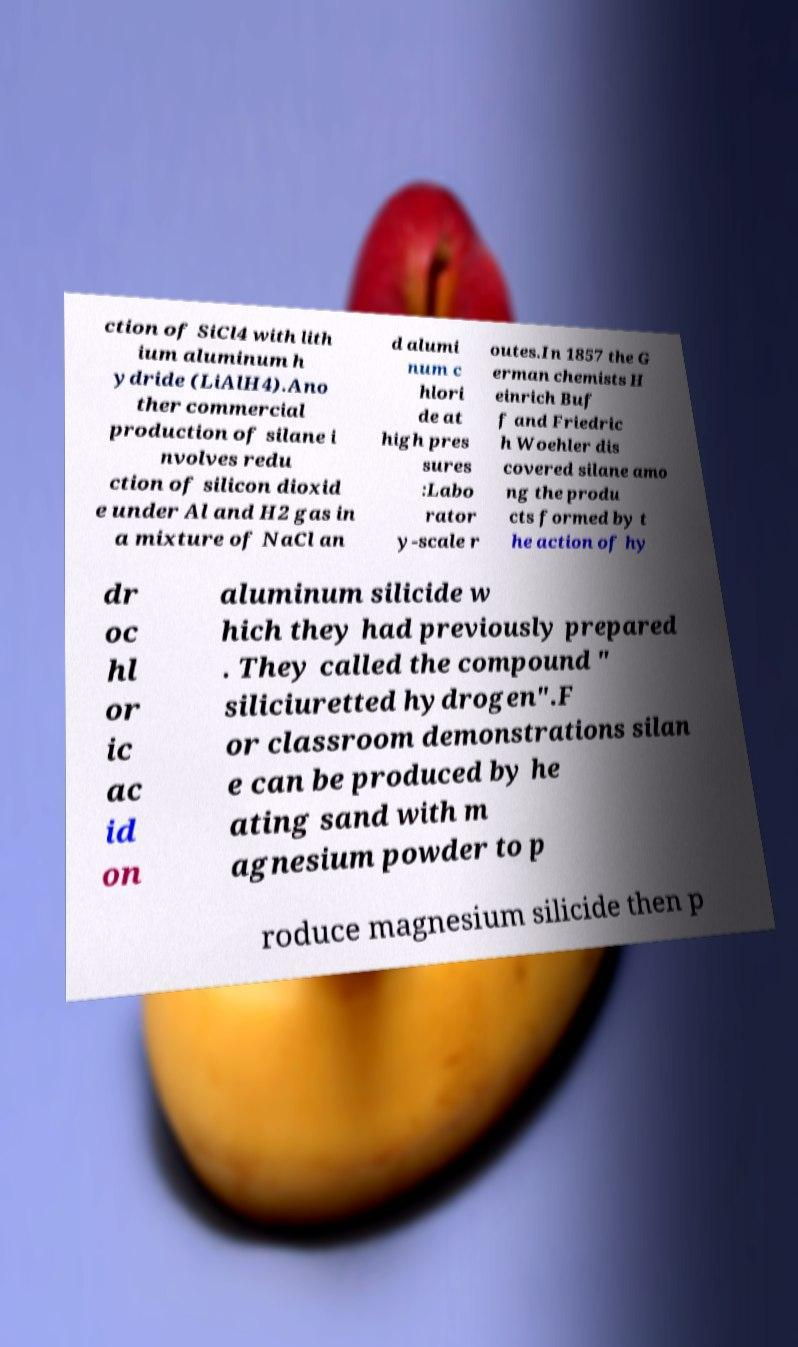Could you extract and type out the text from this image? ction of SiCl4 with lith ium aluminum h ydride (LiAlH4).Ano ther commercial production of silane i nvolves redu ction of silicon dioxid e under Al and H2 gas in a mixture of NaCl an d alumi num c hlori de at high pres sures :Labo rator y-scale r outes.In 1857 the G erman chemists H einrich Buf f and Friedric h Woehler dis covered silane amo ng the produ cts formed by t he action of hy dr oc hl or ic ac id on aluminum silicide w hich they had previously prepared . They called the compound " siliciuretted hydrogen".F or classroom demonstrations silan e can be produced by he ating sand with m agnesium powder to p roduce magnesium silicide then p 